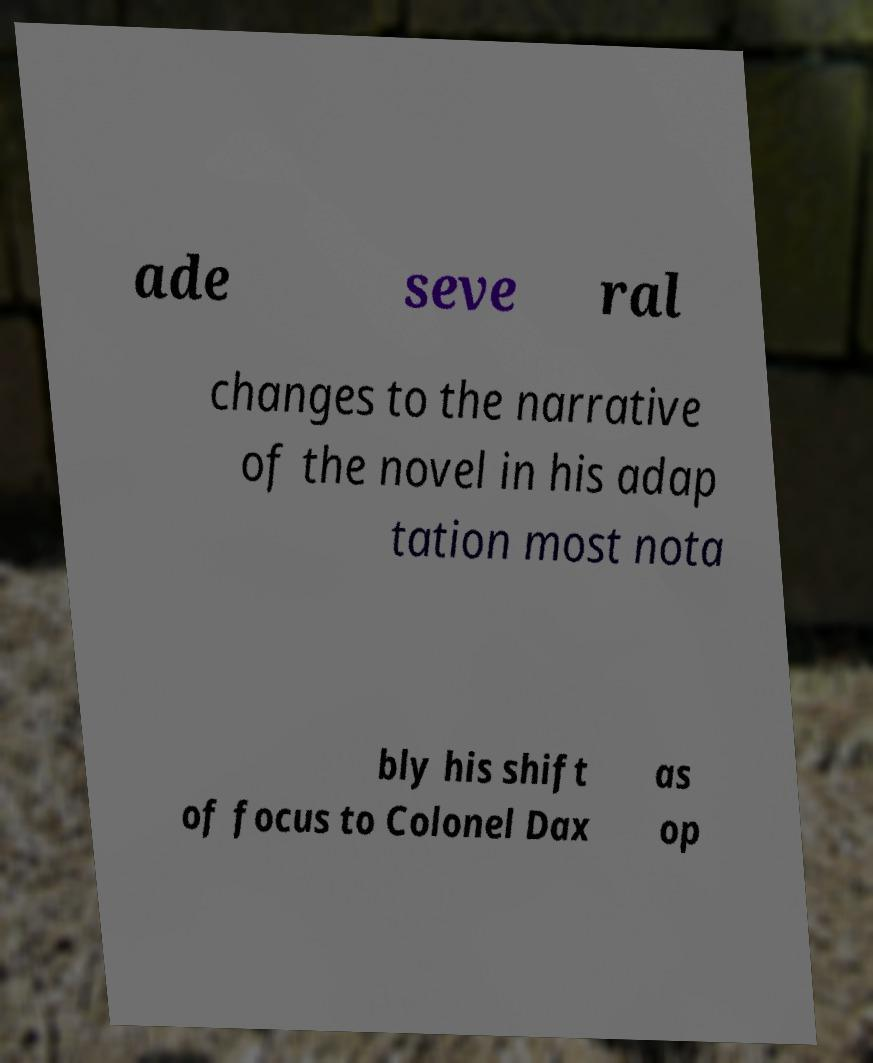Can you accurately transcribe the text from the provided image for me? ade seve ral changes to the narrative of the novel in his adap tation most nota bly his shift of focus to Colonel Dax as op 